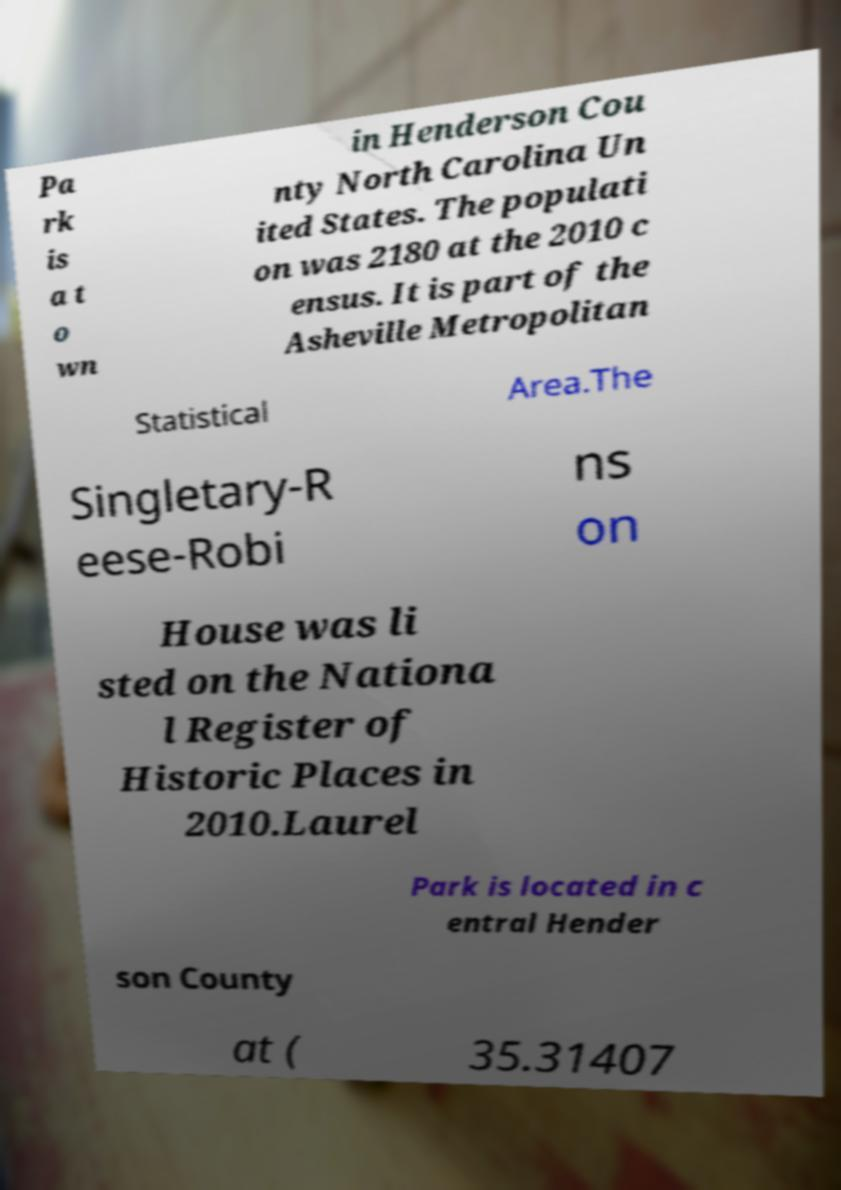I need the written content from this picture converted into text. Can you do that? Pa rk is a t o wn in Henderson Cou nty North Carolina Un ited States. The populati on was 2180 at the 2010 c ensus. It is part of the Asheville Metropolitan Statistical Area.The Singletary-R eese-Robi ns on House was li sted on the Nationa l Register of Historic Places in 2010.Laurel Park is located in c entral Hender son County at ( 35.31407 